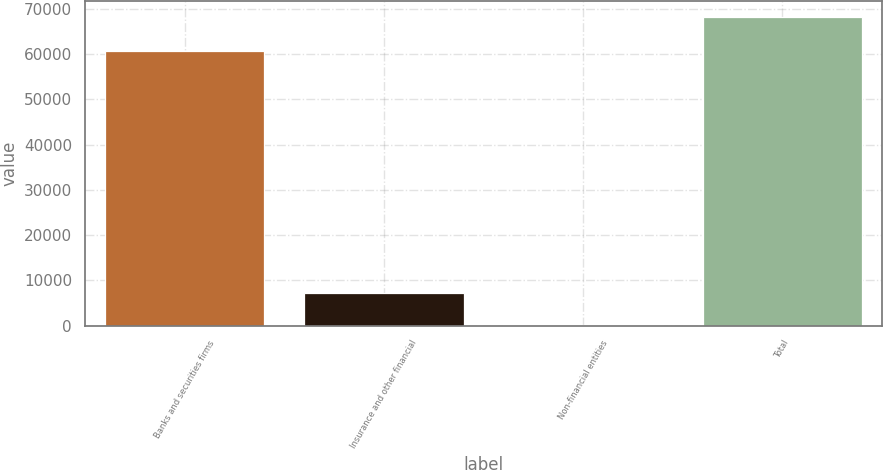<chart> <loc_0><loc_0><loc_500><loc_500><bar_chart><fcel>Banks and securities firms<fcel>Insurance and other financial<fcel>Non-financial entities<fcel>Total<nl><fcel>60728<fcel>7313<fcel>226<fcel>68267<nl></chart> 